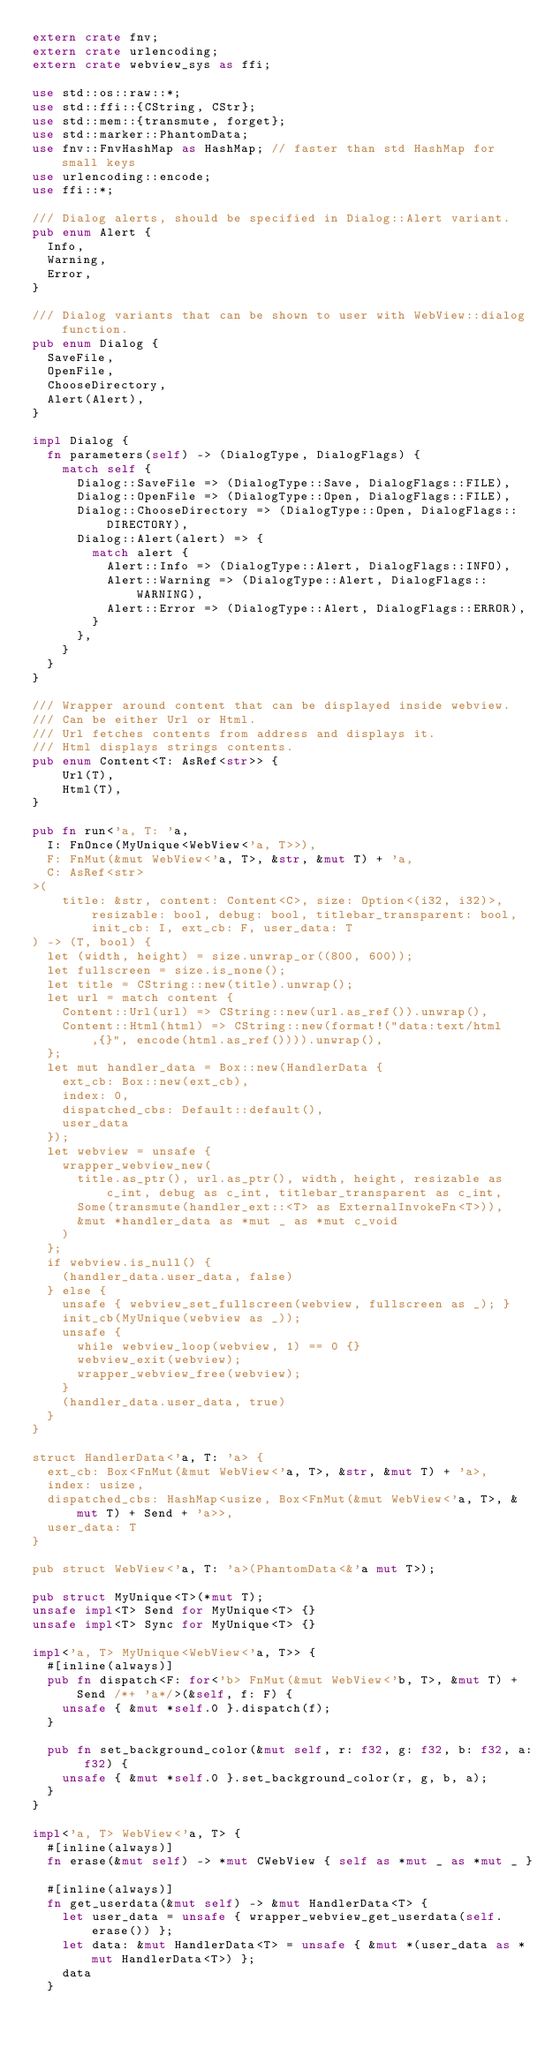Convert code to text. <code><loc_0><loc_0><loc_500><loc_500><_Rust_>extern crate fnv;
extern crate urlencoding;
extern crate webview_sys as ffi;

use std::os::raw::*;
use std::ffi::{CString, CStr};
use std::mem::{transmute, forget};
use std::marker::PhantomData;
use fnv::FnvHashMap as HashMap; // faster than std HashMap for small keys
use urlencoding::encode;
use ffi::*;

/// Dialog alerts, should be specified in Dialog::Alert variant.
pub enum Alert {
	Info,
	Warning,
	Error,
}

/// Dialog variants that can be shown to user with WebView::dialog function.
pub enum Dialog {
	SaveFile,
	OpenFile,
	ChooseDirectory,
	Alert(Alert),
}

impl Dialog {
	fn parameters(self) -> (DialogType, DialogFlags) {
		match self {
			Dialog::SaveFile => (DialogType::Save, DialogFlags::FILE),
			Dialog::OpenFile => (DialogType::Open, DialogFlags::FILE),
			Dialog::ChooseDirectory => (DialogType::Open, DialogFlags::DIRECTORY),
			Dialog::Alert(alert) => {
				match alert {
					Alert::Info => (DialogType::Alert, DialogFlags::INFO),
					Alert::Warning => (DialogType::Alert, DialogFlags::WARNING),
					Alert::Error => (DialogType::Alert, DialogFlags::ERROR),
				}
			},
		}
	}
}

/// Wrapper around content that can be displayed inside webview.
/// Can be either Url or Html.
/// Url fetches contents from address and displays it.
/// Html displays strings contents.
pub enum Content<T: AsRef<str>> {
    Url(T),
    Html(T),
}

pub fn run<'a, T: 'a,
	I: FnOnce(MyUnique<WebView<'a, T>>),
	F: FnMut(&mut WebView<'a, T>, &str, &mut T) + 'a,
	C: AsRef<str>
>(
	  title: &str, content: Content<C>, size: Option<(i32, i32)>, resizable: bool, debug: bool, titlebar_transparent: bool, init_cb: I, ext_cb: F, user_data: T
) -> (T, bool) {
	let (width, height) = size.unwrap_or((800, 600));
	let fullscreen = size.is_none();
	let title = CString::new(title).unwrap();
	let url = match content {
		Content::Url(url) => CString::new(url.as_ref()).unwrap(),
		Content::Html(html) => CString::new(format!("data:text/html,{}", encode(html.as_ref()))).unwrap(),
	};
	let mut handler_data = Box::new(HandlerData {
		ext_cb: Box::new(ext_cb),
		index: 0,
		dispatched_cbs: Default::default(),
		user_data
	});
	let webview = unsafe {
		wrapper_webview_new(
			title.as_ptr(), url.as_ptr(), width, height, resizable as c_int, debug as c_int, titlebar_transparent as c_int,
			Some(transmute(handler_ext::<T> as ExternalInvokeFn<T>)),
			&mut *handler_data as *mut _ as *mut c_void
		)
	};
	if webview.is_null() {
		(handler_data.user_data, false)
	} else {
		unsafe { webview_set_fullscreen(webview, fullscreen as _); }
		init_cb(MyUnique(webview as _));
		unsafe {
			while webview_loop(webview, 1) == 0 {}
			webview_exit(webview);
			wrapper_webview_free(webview);
		}
		(handler_data.user_data, true)
	}
}

struct HandlerData<'a, T: 'a> {
	ext_cb: Box<FnMut(&mut WebView<'a, T>, &str, &mut T) + 'a>,
	index: usize,
	dispatched_cbs: HashMap<usize, Box<FnMut(&mut WebView<'a, T>, &mut T) + Send + 'a>>,
	user_data: T
}

pub struct WebView<'a, T: 'a>(PhantomData<&'a mut T>);

pub struct MyUnique<T>(*mut T);
unsafe impl<T> Send for MyUnique<T> {}
unsafe impl<T> Sync for MyUnique<T> {}

impl<'a, T> MyUnique<WebView<'a, T>> {
	#[inline(always)]
	pub fn dispatch<F: for<'b> FnMut(&mut WebView<'b, T>, &mut T) + Send /*+ 'a*/>(&self, f: F) {
		unsafe { &mut *self.0 }.dispatch(f);
	}

  pub fn set_background_color(&mut self, r: f32, g: f32, b: f32, a: f32) {
    unsafe { &mut *self.0 }.set_background_color(r, g, b, a);
  }
}

impl<'a, T> WebView<'a, T> {
	#[inline(always)]
	fn erase(&mut self) -> *mut CWebView { self as *mut _ as *mut _ }

	#[inline(always)]
	fn get_userdata(&mut self) -> &mut HandlerData<T> {
		let user_data = unsafe { wrapper_webview_get_userdata(self.erase()) };
		let data: &mut HandlerData<T> = unsafe { &mut *(user_data as *mut HandlerData<T>) };
		data
	}
</code> 